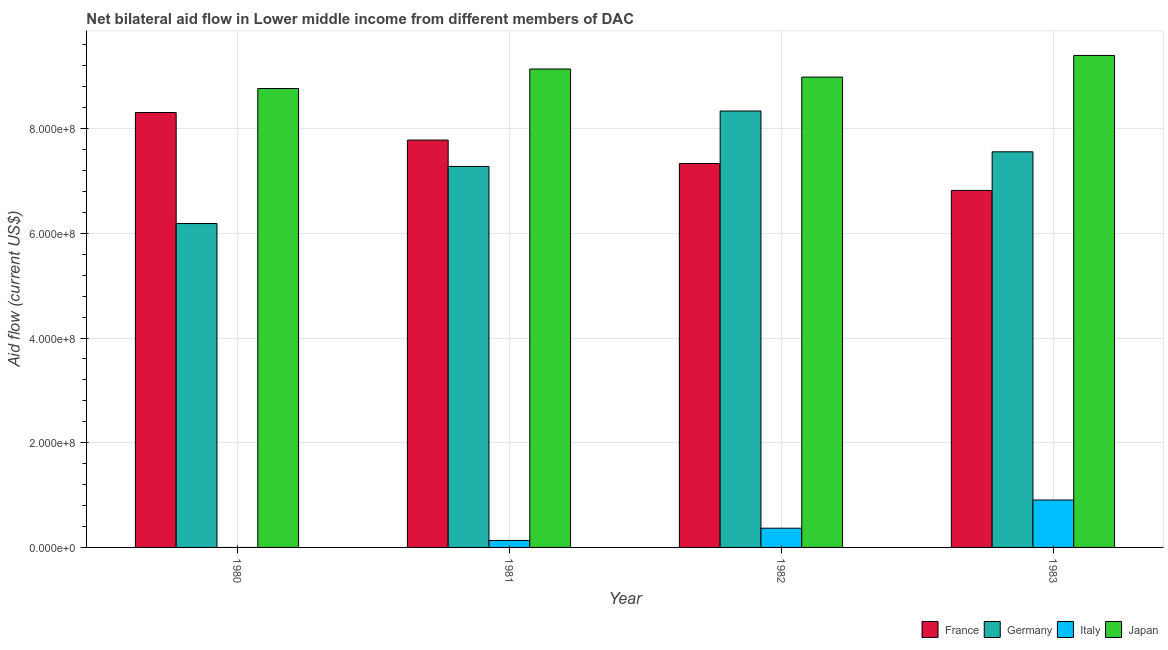How many different coloured bars are there?
Keep it short and to the point. 4. How many groups of bars are there?
Provide a short and direct response. 4. Are the number of bars per tick equal to the number of legend labels?
Provide a succinct answer. No. Are the number of bars on each tick of the X-axis equal?
Make the answer very short. No. How many bars are there on the 3rd tick from the right?
Provide a succinct answer. 4. In how many cases, is the number of bars for a given year not equal to the number of legend labels?
Provide a succinct answer. 1. What is the amount of aid given by japan in 1982?
Your answer should be very brief. 8.98e+08. Across all years, what is the maximum amount of aid given by japan?
Ensure brevity in your answer.  9.40e+08. Across all years, what is the minimum amount of aid given by italy?
Give a very brief answer. 0. What is the total amount of aid given by germany in the graph?
Offer a terse response. 2.94e+09. What is the difference between the amount of aid given by japan in 1982 and that in 1983?
Your answer should be very brief. -4.14e+07. What is the difference between the amount of aid given by italy in 1981 and the amount of aid given by germany in 1982?
Give a very brief answer. -2.34e+07. What is the average amount of aid given by germany per year?
Keep it short and to the point. 7.34e+08. In the year 1981, what is the difference between the amount of aid given by france and amount of aid given by japan?
Provide a short and direct response. 0. In how many years, is the amount of aid given by italy greater than 400000000 US$?
Ensure brevity in your answer.  0. What is the ratio of the amount of aid given by france in 1982 to that in 1983?
Your response must be concise. 1.08. Is the amount of aid given by germany in 1980 less than that in 1982?
Keep it short and to the point. Yes. Is the difference between the amount of aid given by germany in 1982 and 1983 greater than the difference between the amount of aid given by japan in 1982 and 1983?
Ensure brevity in your answer.  No. What is the difference between the highest and the second highest amount of aid given by italy?
Keep it short and to the point. 5.38e+07. What is the difference between the highest and the lowest amount of aid given by france?
Your response must be concise. 1.49e+08. Is the sum of the amount of aid given by italy in 1982 and 1983 greater than the maximum amount of aid given by germany across all years?
Give a very brief answer. Yes. Is it the case that in every year, the sum of the amount of aid given by france and amount of aid given by italy is greater than the sum of amount of aid given by germany and amount of aid given by japan?
Provide a short and direct response. No. Is it the case that in every year, the sum of the amount of aid given by france and amount of aid given by germany is greater than the amount of aid given by italy?
Make the answer very short. Yes. How many bars are there?
Offer a very short reply. 15. Are all the bars in the graph horizontal?
Your answer should be very brief. No. What is the difference between two consecutive major ticks on the Y-axis?
Provide a succinct answer. 2.00e+08. How many legend labels are there?
Offer a terse response. 4. How are the legend labels stacked?
Offer a very short reply. Horizontal. What is the title of the graph?
Keep it short and to the point. Net bilateral aid flow in Lower middle income from different members of DAC. Does "Corruption" appear as one of the legend labels in the graph?
Provide a short and direct response. No. What is the label or title of the Y-axis?
Provide a succinct answer. Aid flow (current US$). What is the Aid flow (current US$) in France in 1980?
Provide a succinct answer. 8.31e+08. What is the Aid flow (current US$) in Germany in 1980?
Your answer should be compact. 6.19e+08. What is the Aid flow (current US$) of Japan in 1980?
Ensure brevity in your answer.  8.77e+08. What is the Aid flow (current US$) of France in 1981?
Provide a succinct answer. 7.78e+08. What is the Aid flow (current US$) in Germany in 1981?
Keep it short and to the point. 7.28e+08. What is the Aid flow (current US$) in Italy in 1981?
Offer a very short reply. 1.33e+07. What is the Aid flow (current US$) in Japan in 1981?
Your response must be concise. 9.14e+08. What is the Aid flow (current US$) of France in 1982?
Your answer should be compact. 7.33e+08. What is the Aid flow (current US$) in Germany in 1982?
Your answer should be compact. 8.34e+08. What is the Aid flow (current US$) of Italy in 1982?
Offer a terse response. 3.67e+07. What is the Aid flow (current US$) of Japan in 1982?
Offer a terse response. 8.98e+08. What is the Aid flow (current US$) in France in 1983?
Give a very brief answer. 6.82e+08. What is the Aid flow (current US$) in Germany in 1983?
Give a very brief answer. 7.56e+08. What is the Aid flow (current US$) in Italy in 1983?
Offer a very short reply. 9.05e+07. What is the Aid flow (current US$) of Japan in 1983?
Give a very brief answer. 9.40e+08. Across all years, what is the maximum Aid flow (current US$) in France?
Give a very brief answer. 8.31e+08. Across all years, what is the maximum Aid flow (current US$) of Germany?
Provide a short and direct response. 8.34e+08. Across all years, what is the maximum Aid flow (current US$) in Italy?
Keep it short and to the point. 9.05e+07. Across all years, what is the maximum Aid flow (current US$) in Japan?
Your response must be concise. 9.40e+08. Across all years, what is the minimum Aid flow (current US$) of France?
Your response must be concise. 6.82e+08. Across all years, what is the minimum Aid flow (current US$) of Germany?
Give a very brief answer. 6.19e+08. Across all years, what is the minimum Aid flow (current US$) in Italy?
Give a very brief answer. 0. Across all years, what is the minimum Aid flow (current US$) of Japan?
Your answer should be very brief. 8.77e+08. What is the total Aid flow (current US$) of France in the graph?
Provide a short and direct response. 3.02e+09. What is the total Aid flow (current US$) of Germany in the graph?
Your response must be concise. 2.94e+09. What is the total Aid flow (current US$) of Italy in the graph?
Offer a very short reply. 1.41e+08. What is the total Aid flow (current US$) of Japan in the graph?
Make the answer very short. 3.63e+09. What is the difference between the Aid flow (current US$) of France in 1980 and that in 1981?
Your response must be concise. 5.27e+07. What is the difference between the Aid flow (current US$) of Germany in 1980 and that in 1981?
Ensure brevity in your answer.  -1.09e+08. What is the difference between the Aid flow (current US$) in Japan in 1980 and that in 1981?
Offer a terse response. -3.73e+07. What is the difference between the Aid flow (current US$) in France in 1980 and that in 1982?
Your answer should be compact. 9.75e+07. What is the difference between the Aid flow (current US$) in Germany in 1980 and that in 1982?
Provide a succinct answer. -2.15e+08. What is the difference between the Aid flow (current US$) of Japan in 1980 and that in 1982?
Offer a terse response. -2.18e+07. What is the difference between the Aid flow (current US$) of France in 1980 and that in 1983?
Make the answer very short. 1.49e+08. What is the difference between the Aid flow (current US$) in Germany in 1980 and that in 1983?
Your answer should be compact. -1.37e+08. What is the difference between the Aid flow (current US$) of Japan in 1980 and that in 1983?
Offer a terse response. -6.32e+07. What is the difference between the Aid flow (current US$) in France in 1981 and that in 1982?
Give a very brief answer. 4.48e+07. What is the difference between the Aid flow (current US$) of Germany in 1981 and that in 1982?
Ensure brevity in your answer.  -1.06e+08. What is the difference between the Aid flow (current US$) of Italy in 1981 and that in 1982?
Offer a terse response. -2.34e+07. What is the difference between the Aid flow (current US$) of Japan in 1981 and that in 1982?
Offer a terse response. 1.55e+07. What is the difference between the Aid flow (current US$) in France in 1981 and that in 1983?
Ensure brevity in your answer.  9.62e+07. What is the difference between the Aid flow (current US$) in Germany in 1981 and that in 1983?
Ensure brevity in your answer.  -2.79e+07. What is the difference between the Aid flow (current US$) of Italy in 1981 and that in 1983?
Provide a short and direct response. -7.72e+07. What is the difference between the Aid flow (current US$) in Japan in 1981 and that in 1983?
Offer a terse response. -2.59e+07. What is the difference between the Aid flow (current US$) in France in 1982 and that in 1983?
Keep it short and to the point. 5.14e+07. What is the difference between the Aid flow (current US$) in Germany in 1982 and that in 1983?
Offer a terse response. 7.80e+07. What is the difference between the Aid flow (current US$) of Italy in 1982 and that in 1983?
Ensure brevity in your answer.  -5.38e+07. What is the difference between the Aid flow (current US$) of Japan in 1982 and that in 1983?
Your answer should be very brief. -4.14e+07. What is the difference between the Aid flow (current US$) of France in 1980 and the Aid flow (current US$) of Germany in 1981?
Give a very brief answer. 1.03e+08. What is the difference between the Aid flow (current US$) in France in 1980 and the Aid flow (current US$) in Italy in 1981?
Your answer should be very brief. 8.18e+08. What is the difference between the Aid flow (current US$) in France in 1980 and the Aid flow (current US$) in Japan in 1981?
Ensure brevity in your answer.  -8.31e+07. What is the difference between the Aid flow (current US$) of Germany in 1980 and the Aid flow (current US$) of Italy in 1981?
Your answer should be compact. 6.05e+08. What is the difference between the Aid flow (current US$) of Germany in 1980 and the Aid flow (current US$) of Japan in 1981?
Keep it short and to the point. -2.95e+08. What is the difference between the Aid flow (current US$) of France in 1980 and the Aid flow (current US$) of Germany in 1982?
Make the answer very short. -2.85e+06. What is the difference between the Aid flow (current US$) of France in 1980 and the Aid flow (current US$) of Italy in 1982?
Your response must be concise. 7.94e+08. What is the difference between the Aid flow (current US$) in France in 1980 and the Aid flow (current US$) in Japan in 1982?
Provide a short and direct response. -6.76e+07. What is the difference between the Aid flow (current US$) in Germany in 1980 and the Aid flow (current US$) in Italy in 1982?
Your response must be concise. 5.82e+08. What is the difference between the Aid flow (current US$) in Germany in 1980 and the Aid flow (current US$) in Japan in 1982?
Keep it short and to the point. -2.80e+08. What is the difference between the Aid flow (current US$) in France in 1980 and the Aid flow (current US$) in Germany in 1983?
Make the answer very short. 7.51e+07. What is the difference between the Aid flow (current US$) of France in 1980 and the Aid flow (current US$) of Italy in 1983?
Ensure brevity in your answer.  7.40e+08. What is the difference between the Aid flow (current US$) in France in 1980 and the Aid flow (current US$) in Japan in 1983?
Ensure brevity in your answer.  -1.09e+08. What is the difference between the Aid flow (current US$) in Germany in 1980 and the Aid flow (current US$) in Italy in 1983?
Make the answer very short. 5.28e+08. What is the difference between the Aid flow (current US$) in Germany in 1980 and the Aid flow (current US$) in Japan in 1983?
Give a very brief answer. -3.21e+08. What is the difference between the Aid flow (current US$) in France in 1981 and the Aid flow (current US$) in Germany in 1982?
Keep it short and to the point. -5.55e+07. What is the difference between the Aid flow (current US$) of France in 1981 and the Aid flow (current US$) of Italy in 1982?
Make the answer very short. 7.41e+08. What is the difference between the Aid flow (current US$) of France in 1981 and the Aid flow (current US$) of Japan in 1982?
Your answer should be very brief. -1.20e+08. What is the difference between the Aid flow (current US$) of Germany in 1981 and the Aid flow (current US$) of Italy in 1982?
Provide a short and direct response. 6.91e+08. What is the difference between the Aid flow (current US$) of Germany in 1981 and the Aid flow (current US$) of Japan in 1982?
Your answer should be compact. -1.71e+08. What is the difference between the Aid flow (current US$) in Italy in 1981 and the Aid flow (current US$) in Japan in 1982?
Offer a very short reply. -8.85e+08. What is the difference between the Aid flow (current US$) in France in 1981 and the Aid flow (current US$) in Germany in 1983?
Your answer should be very brief. 2.24e+07. What is the difference between the Aid flow (current US$) of France in 1981 and the Aid flow (current US$) of Italy in 1983?
Your answer should be compact. 6.88e+08. What is the difference between the Aid flow (current US$) of France in 1981 and the Aid flow (current US$) of Japan in 1983?
Provide a short and direct response. -1.62e+08. What is the difference between the Aid flow (current US$) of Germany in 1981 and the Aid flow (current US$) of Italy in 1983?
Your answer should be compact. 6.37e+08. What is the difference between the Aid flow (current US$) of Germany in 1981 and the Aid flow (current US$) of Japan in 1983?
Provide a short and direct response. -2.12e+08. What is the difference between the Aid flow (current US$) of Italy in 1981 and the Aid flow (current US$) of Japan in 1983?
Your answer should be very brief. -9.27e+08. What is the difference between the Aid flow (current US$) of France in 1982 and the Aid flow (current US$) of Germany in 1983?
Provide a short and direct response. -2.24e+07. What is the difference between the Aid flow (current US$) in France in 1982 and the Aid flow (current US$) in Italy in 1983?
Your answer should be compact. 6.43e+08. What is the difference between the Aid flow (current US$) in France in 1982 and the Aid flow (current US$) in Japan in 1983?
Your answer should be very brief. -2.07e+08. What is the difference between the Aid flow (current US$) in Germany in 1982 and the Aid flow (current US$) in Italy in 1983?
Your answer should be very brief. 7.43e+08. What is the difference between the Aid flow (current US$) of Germany in 1982 and the Aid flow (current US$) of Japan in 1983?
Make the answer very short. -1.06e+08. What is the difference between the Aid flow (current US$) in Italy in 1982 and the Aid flow (current US$) in Japan in 1983?
Make the answer very short. -9.03e+08. What is the average Aid flow (current US$) in France per year?
Offer a very short reply. 7.56e+08. What is the average Aid flow (current US$) in Germany per year?
Ensure brevity in your answer.  7.34e+08. What is the average Aid flow (current US$) in Italy per year?
Offer a terse response. 3.52e+07. What is the average Aid flow (current US$) of Japan per year?
Your answer should be compact. 9.07e+08. In the year 1980, what is the difference between the Aid flow (current US$) of France and Aid flow (current US$) of Germany?
Keep it short and to the point. 2.12e+08. In the year 1980, what is the difference between the Aid flow (current US$) in France and Aid flow (current US$) in Japan?
Keep it short and to the point. -4.58e+07. In the year 1980, what is the difference between the Aid flow (current US$) in Germany and Aid flow (current US$) in Japan?
Your response must be concise. -2.58e+08. In the year 1981, what is the difference between the Aid flow (current US$) of France and Aid flow (current US$) of Germany?
Provide a short and direct response. 5.04e+07. In the year 1981, what is the difference between the Aid flow (current US$) of France and Aid flow (current US$) of Italy?
Offer a very short reply. 7.65e+08. In the year 1981, what is the difference between the Aid flow (current US$) of France and Aid flow (current US$) of Japan?
Your answer should be compact. -1.36e+08. In the year 1981, what is the difference between the Aid flow (current US$) of Germany and Aid flow (current US$) of Italy?
Provide a short and direct response. 7.14e+08. In the year 1981, what is the difference between the Aid flow (current US$) of Germany and Aid flow (current US$) of Japan?
Provide a short and direct response. -1.86e+08. In the year 1981, what is the difference between the Aid flow (current US$) in Italy and Aid flow (current US$) in Japan?
Your answer should be very brief. -9.01e+08. In the year 1982, what is the difference between the Aid flow (current US$) of France and Aid flow (current US$) of Germany?
Your response must be concise. -1.00e+08. In the year 1982, what is the difference between the Aid flow (current US$) in France and Aid flow (current US$) in Italy?
Your response must be concise. 6.97e+08. In the year 1982, what is the difference between the Aid flow (current US$) of France and Aid flow (current US$) of Japan?
Your response must be concise. -1.65e+08. In the year 1982, what is the difference between the Aid flow (current US$) in Germany and Aid flow (current US$) in Italy?
Offer a very short reply. 7.97e+08. In the year 1982, what is the difference between the Aid flow (current US$) in Germany and Aid flow (current US$) in Japan?
Keep it short and to the point. -6.48e+07. In the year 1982, what is the difference between the Aid flow (current US$) of Italy and Aid flow (current US$) of Japan?
Provide a succinct answer. -8.62e+08. In the year 1983, what is the difference between the Aid flow (current US$) in France and Aid flow (current US$) in Germany?
Keep it short and to the point. -7.38e+07. In the year 1983, what is the difference between the Aid flow (current US$) in France and Aid flow (current US$) in Italy?
Provide a short and direct response. 5.91e+08. In the year 1983, what is the difference between the Aid flow (current US$) of France and Aid flow (current US$) of Japan?
Your answer should be compact. -2.58e+08. In the year 1983, what is the difference between the Aid flow (current US$) in Germany and Aid flow (current US$) in Italy?
Give a very brief answer. 6.65e+08. In the year 1983, what is the difference between the Aid flow (current US$) of Germany and Aid flow (current US$) of Japan?
Your answer should be very brief. -1.84e+08. In the year 1983, what is the difference between the Aid flow (current US$) of Italy and Aid flow (current US$) of Japan?
Your answer should be compact. -8.49e+08. What is the ratio of the Aid flow (current US$) in France in 1980 to that in 1981?
Your response must be concise. 1.07. What is the ratio of the Aid flow (current US$) of Germany in 1980 to that in 1981?
Provide a succinct answer. 0.85. What is the ratio of the Aid flow (current US$) in Japan in 1980 to that in 1981?
Offer a very short reply. 0.96. What is the ratio of the Aid flow (current US$) in France in 1980 to that in 1982?
Your answer should be compact. 1.13. What is the ratio of the Aid flow (current US$) in Germany in 1980 to that in 1982?
Offer a very short reply. 0.74. What is the ratio of the Aid flow (current US$) of Japan in 1980 to that in 1982?
Offer a very short reply. 0.98. What is the ratio of the Aid flow (current US$) of France in 1980 to that in 1983?
Your answer should be very brief. 1.22. What is the ratio of the Aid flow (current US$) of Germany in 1980 to that in 1983?
Offer a terse response. 0.82. What is the ratio of the Aid flow (current US$) in Japan in 1980 to that in 1983?
Your response must be concise. 0.93. What is the ratio of the Aid flow (current US$) of France in 1981 to that in 1982?
Your response must be concise. 1.06. What is the ratio of the Aid flow (current US$) in Germany in 1981 to that in 1982?
Offer a very short reply. 0.87. What is the ratio of the Aid flow (current US$) of Italy in 1981 to that in 1982?
Ensure brevity in your answer.  0.36. What is the ratio of the Aid flow (current US$) of Japan in 1981 to that in 1982?
Make the answer very short. 1.02. What is the ratio of the Aid flow (current US$) of France in 1981 to that in 1983?
Your answer should be very brief. 1.14. What is the ratio of the Aid flow (current US$) of Germany in 1981 to that in 1983?
Your answer should be compact. 0.96. What is the ratio of the Aid flow (current US$) of Italy in 1981 to that in 1983?
Your answer should be very brief. 0.15. What is the ratio of the Aid flow (current US$) in Japan in 1981 to that in 1983?
Your response must be concise. 0.97. What is the ratio of the Aid flow (current US$) in France in 1982 to that in 1983?
Ensure brevity in your answer.  1.08. What is the ratio of the Aid flow (current US$) in Germany in 1982 to that in 1983?
Your answer should be very brief. 1.1. What is the ratio of the Aid flow (current US$) in Italy in 1982 to that in 1983?
Ensure brevity in your answer.  0.41. What is the ratio of the Aid flow (current US$) of Japan in 1982 to that in 1983?
Keep it short and to the point. 0.96. What is the difference between the highest and the second highest Aid flow (current US$) of France?
Offer a terse response. 5.27e+07. What is the difference between the highest and the second highest Aid flow (current US$) of Germany?
Your answer should be compact. 7.80e+07. What is the difference between the highest and the second highest Aid flow (current US$) in Italy?
Provide a short and direct response. 5.38e+07. What is the difference between the highest and the second highest Aid flow (current US$) of Japan?
Your answer should be very brief. 2.59e+07. What is the difference between the highest and the lowest Aid flow (current US$) in France?
Your response must be concise. 1.49e+08. What is the difference between the highest and the lowest Aid flow (current US$) in Germany?
Your response must be concise. 2.15e+08. What is the difference between the highest and the lowest Aid flow (current US$) in Italy?
Your answer should be very brief. 9.05e+07. What is the difference between the highest and the lowest Aid flow (current US$) of Japan?
Your answer should be very brief. 6.32e+07. 